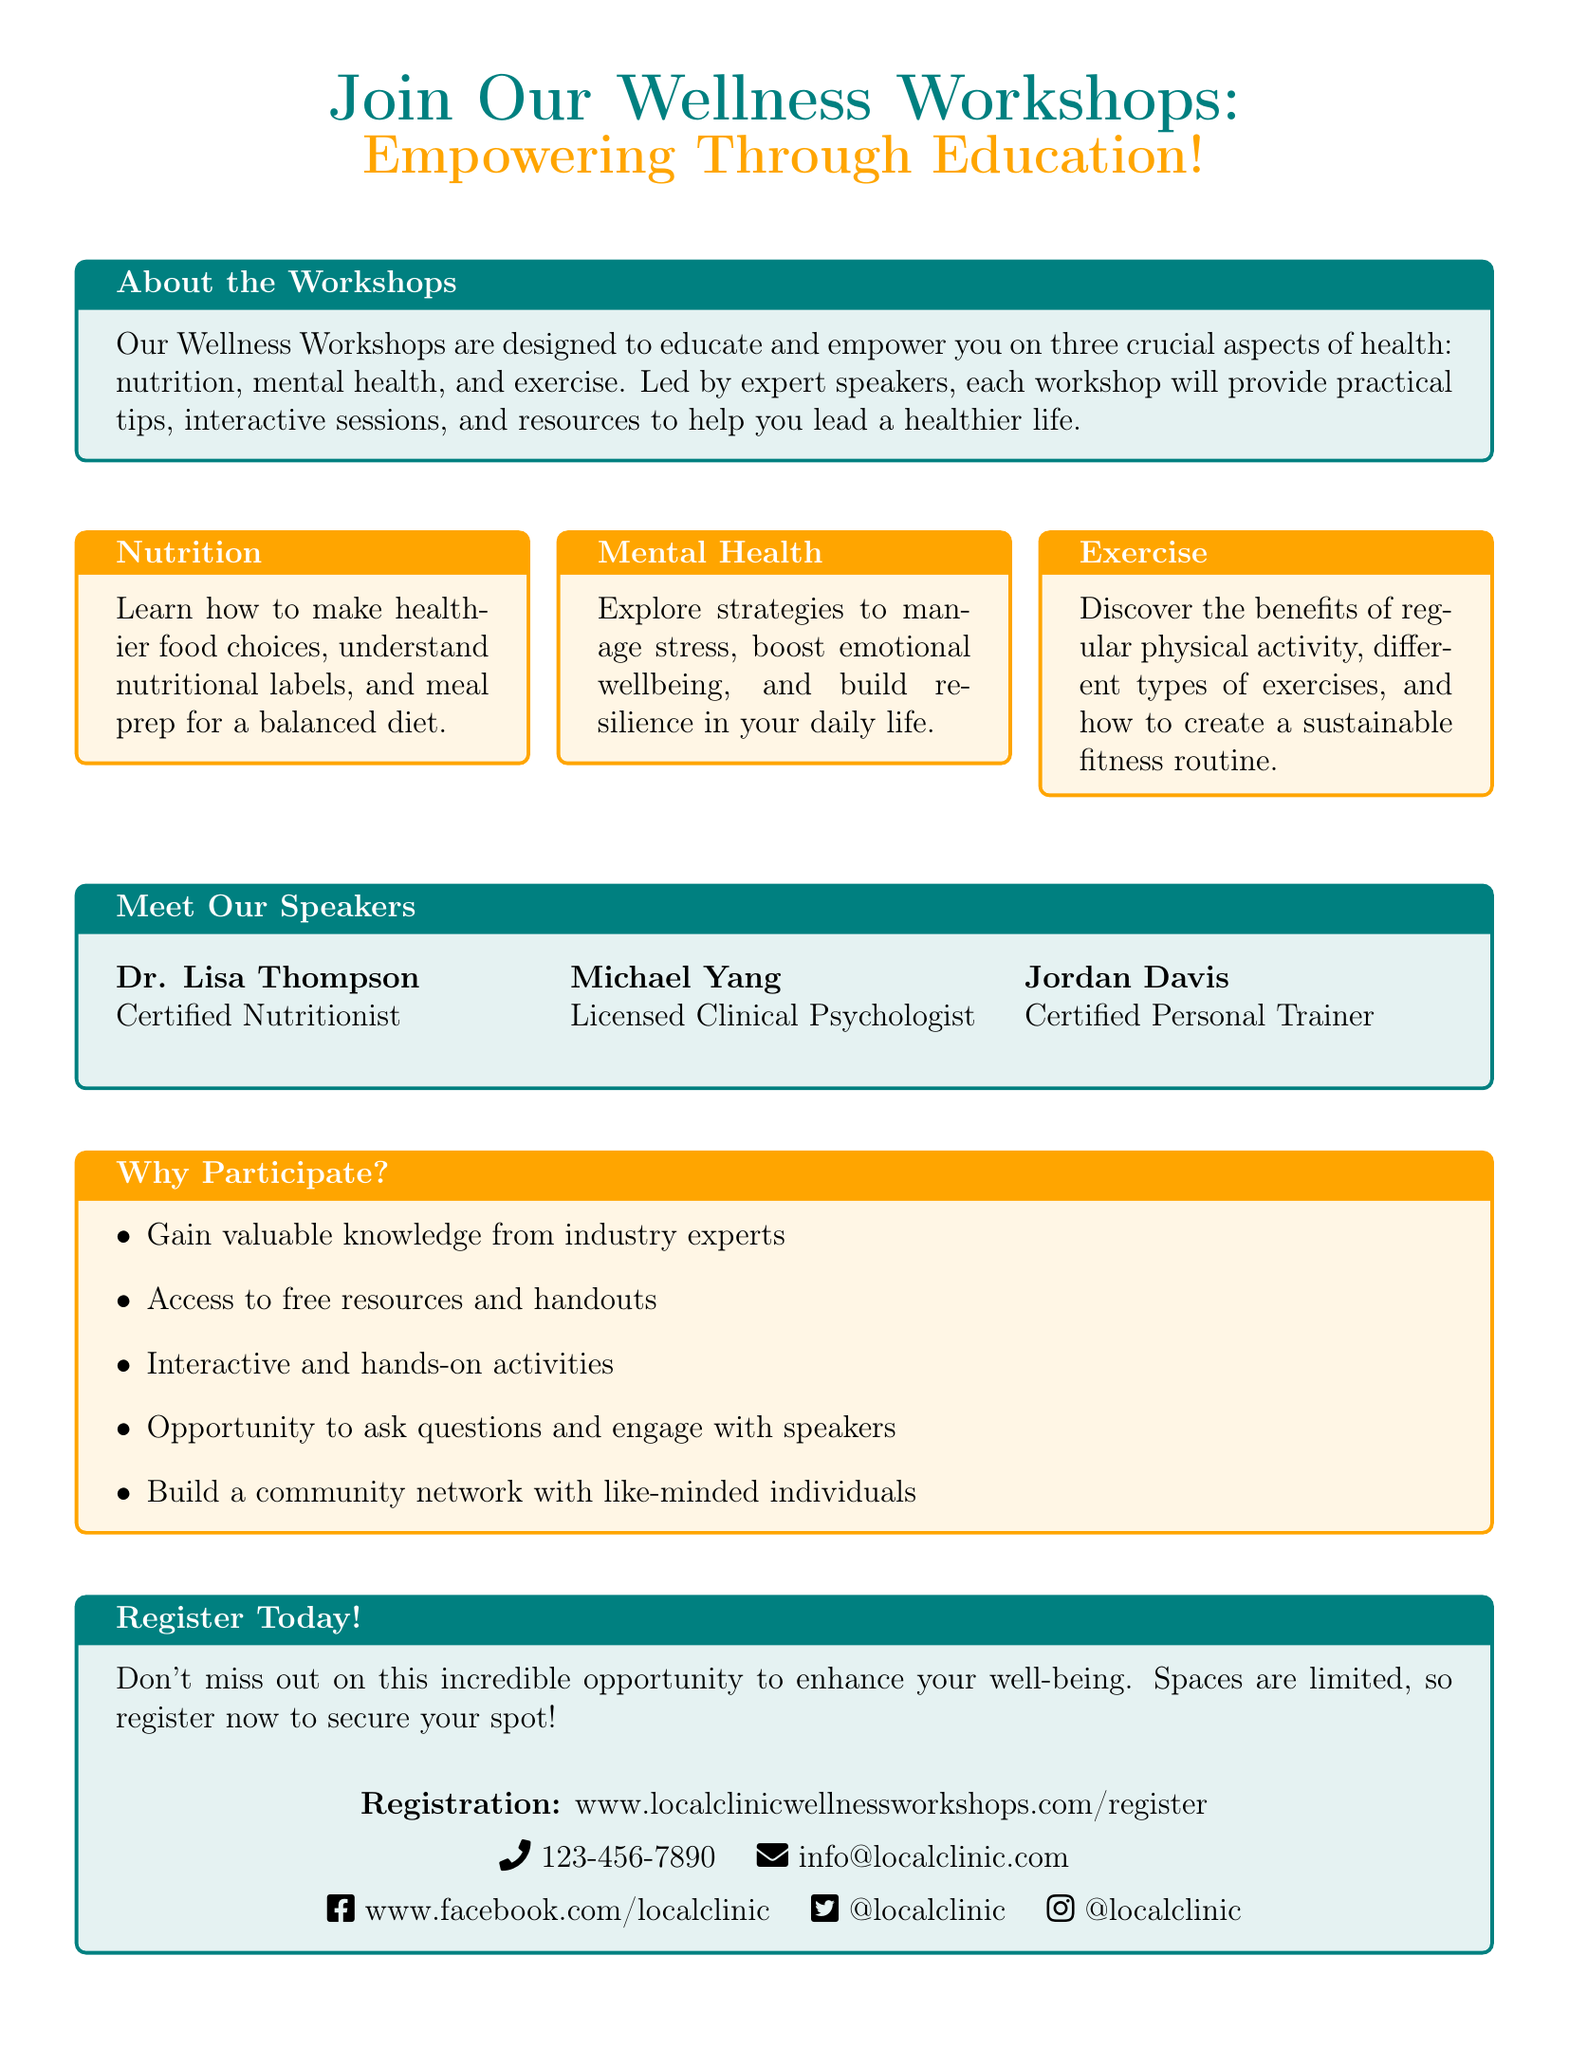What are the three aspects of health covered in the workshops? The document states that the workshops cover three crucial aspects of health, which are nutrition, mental health, and exercise.
Answer: nutrition, mental health, exercise Who is a certified nutritionist among the speakers? The document lists Dr. Lisa Thompson as a certified nutritionist.
Answer: Dr. Lisa Thompson What is the registration website for the workshops? The document provides a specific website where individuals can register for the workshops.
Answer: www.localclinicwellnessworkshops.com/register What is the phone number provided for inquiries? The document includes a contact phone number for further inquiries about the workshops.
Answer: 123-456-7890 Why should someone participate in the workshops? The document lists several reasons to participate, such as gaining knowledge and building community networks, among others.
Answer: Gain valuable knowledge from industry experts What type of activities can participants expect at the workshops? The document explains that the workshops include interactive and hands-on activities.
Answer: Interactive and hands-on activities Who is the licensed clinical psychologist among the speakers? The document identifies Michael Yang as the licensed clinical psychologist featured in the workshops.
Answer: Michael Yang What can attendees access for free during the workshops? The document states that participants will have access to free resources and handouts.
Answer: Free resources and handouts 